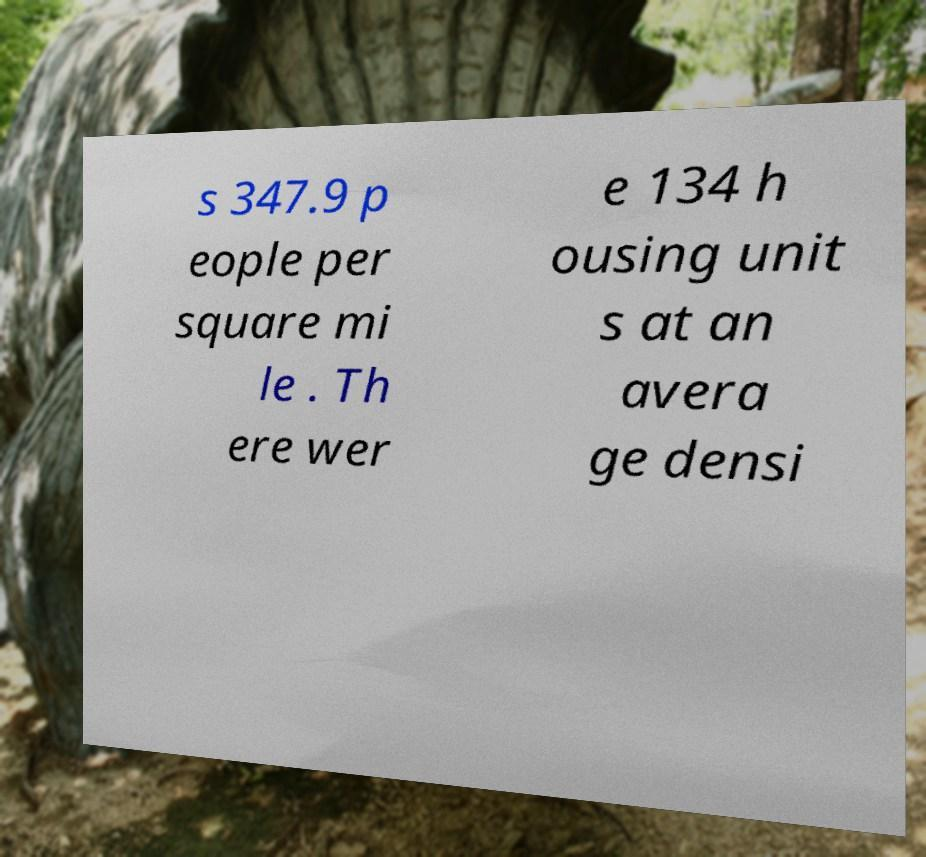There's text embedded in this image that I need extracted. Can you transcribe it verbatim? s 347.9 p eople per square mi le . Th ere wer e 134 h ousing unit s at an avera ge densi 